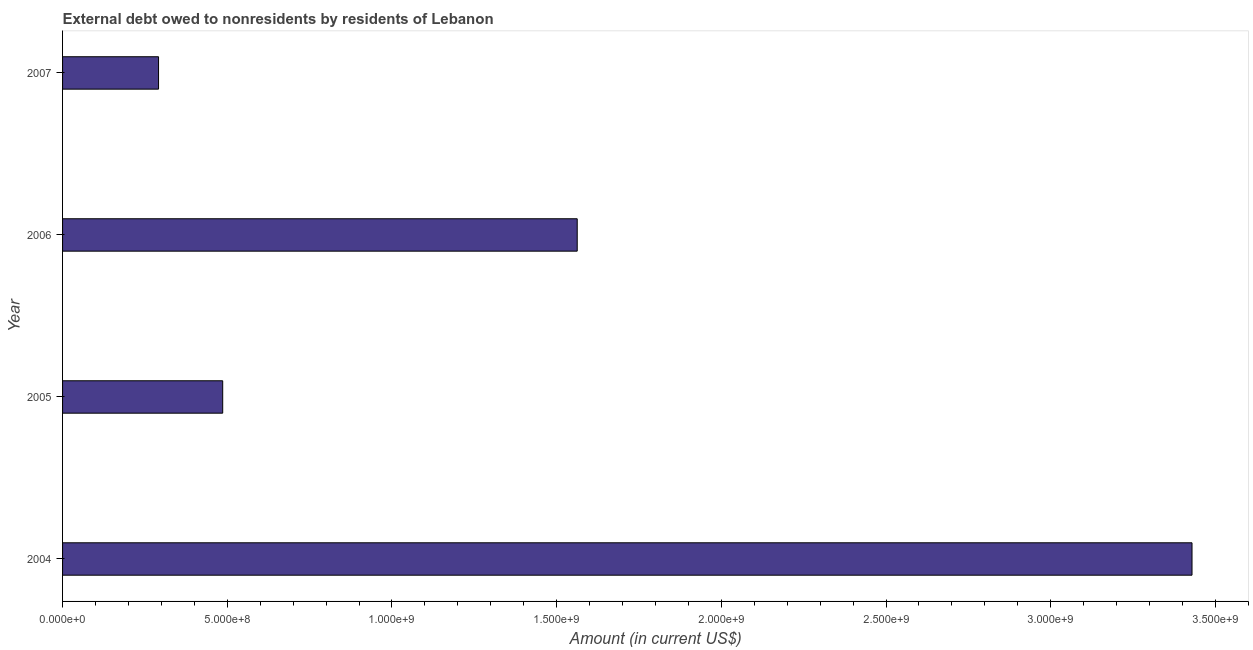Does the graph contain grids?
Provide a succinct answer. No. What is the title of the graph?
Keep it short and to the point. External debt owed to nonresidents by residents of Lebanon. What is the label or title of the X-axis?
Your answer should be very brief. Amount (in current US$). What is the label or title of the Y-axis?
Ensure brevity in your answer.  Year. What is the debt in 2006?
Keep it short and to the point. 1.56e+09. Across all years, what is the maximum debt?
Offer a very short reply. 3.43e+09. Across all years, what is the minimum debt?
Your answer should be very brief. 2.91e+08. In which year was the debt maximum?
Give a very brief answer. 2004. In which year was the debt minimum?
Your response must be concise. 2007. What is the sum of the debt?
Your answer should be compact. 5.77e+09. What is the difference between the debt in 2005 and 2006?
Provide a short and direct response. -1.08e+09. What is the average debt per year?
Make the answer very short. 1.44e+09. What is the median debt?
Give a very brief answer. 1.02e+09. In how many years, is the debt greater than 3300000000 US$?
Your answer should be compact. 1. What is the ratio of the debt in 2006 to that in 2007?
Give a very brief answer. 5.36. Is the debt in 2004 less than that in 2006?
Give a very brief answer. No. Is the difference between the debt in 2004 and 2007 greater than the difference between any two years?
Your response must be concise. Yes. What is the difference between the highest and the second highest debt?
Give a very brief answer. 1.87e+09. Is the sum of the debt in 2004 and 2005 greater than the maximum debt across all years?
Provide a short and direct response. Yes. What is the difference between the highest and the lowest debt?
Give a very brief answer. 3.14e+09. In how many years, is the debt greater than the average debt taken over all years?
Offer a terse response. 2. Are all the bars in the graph horizontal?
Provide a short and direct response. Yes. How many years are there in the graph?
Give a very brief answer. 4. What is the difference between two consecutive major ticks on the X-axis?
Give a very brief answer. 5.00e+08. What is the Amount (in current US$) in 2004?
Your answer should be compact. 3.43e+09. What is the Amount (in current US$) of 2005?
Your answer should be very brief. 4.86e+08. What is the Amount (in current US$) in 2006?
Give a very brief answer. 1.56e+09. What is the Amount (in current US$) of 2007?
Ensure brevity in your answer.  2.91e+08. What is the difference between the Amount (in current US$) in 2004 and 2005?
Keep it short and to the point. 2.94e+09. What is the difference between the Amount (in current US$) in 2004 and 2006?
Your answer should be very brief. 1.87e+09. What is the difference between the Amount (in current US$) in 2004 and 2007?
Ensure brevity in your answer.  3.14e+09. What is the difference between the Amount (in current US$) in 2005 and 2006?
Provide a short and direct response. -1.08e+09. What is the difference between the Amount (in current US$) in 2005 and 2007?
Make the answer very short. 1.95e+08. What is the difference between the Amount (in current US$) in 2006 and 2007?
Give a very brief answer. 1.27e+09. What is the ratio of the Amount (in current US$) in 2004 to that in 2005?
Your response must be concise. 7.05. What is the ratio of the Amount (in current US$) in 2004 to that in 2006?
Your answer should be compact. 2.19. What is the ratio of the Amount (in current US$) in 2004 to that in 2007?
Ensure brevity in your answer.  11.77. What is the ratio of the Amount (in current US$) in 2005 to that in 2006?
Ensure brevity in your answer.  0.31. What is the ratio of the Amount (in current US$) in 2005 to that in 2007?
Provide a succinct answer. 1.67. What is the ratio of the Amount (in current US$) in 2006 to that in 2007?
Keep it short and to the point. 5.36. 